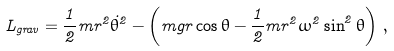Convert formula to latex. <formula><loc_0><loc_0><loc_500><loc_500>L _ { g r a v } = \frac { 1 } { 2 } m r ^ { 2 } \dot { \theta } ^ { 2 } - \left ( m g r \cos \theta - \frac { 1 } { 2 } m r ^ { 2 } \omega ^ { 2 } \sin ^ { 2 } \theta \right ) \, ,</formula> 